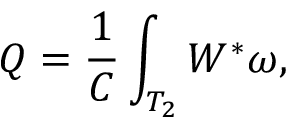<formula> <loc_0><loc_0><loc_500><loc_500>Q = \frac { 1 } { C } \int _ { T _ { 2 } } W ^ { * } \omega ,</formula> 